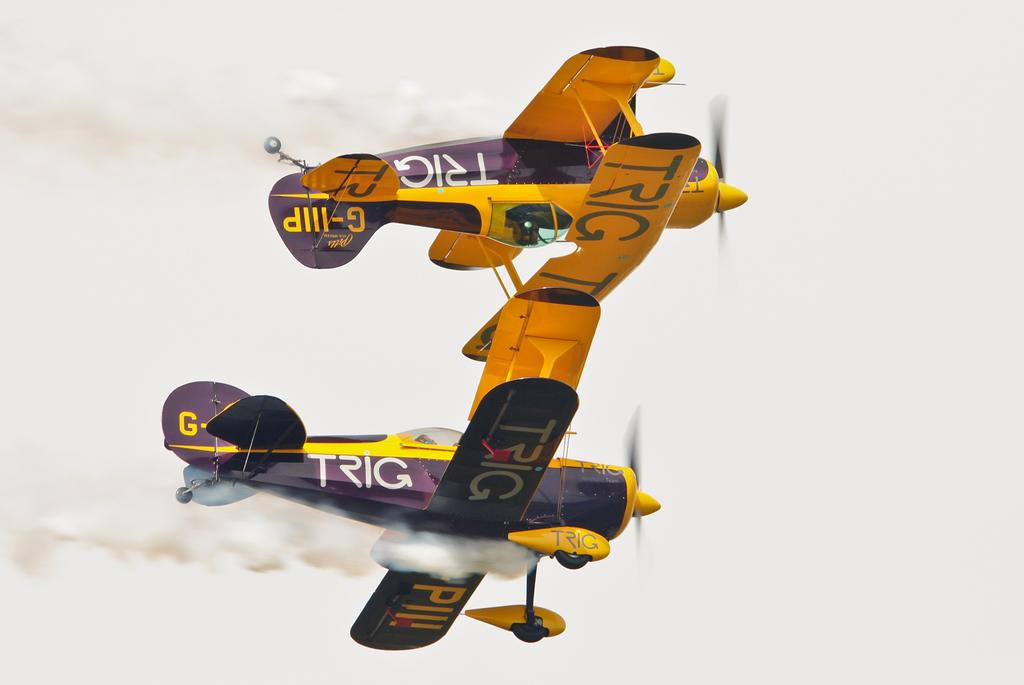What can be seen in the background of the image? The sky is visible in the background of the image. What is the main subject of the image? There are airplanes in the image. What else is present in the image besides the airplanes? Smoke is visible in the image. Where is your aunt sitting in the image? There is no aunt present in the image. What type of crack is visible on the airplane's surface in the image? There is no crack visible on the airplane's surface in the image. 